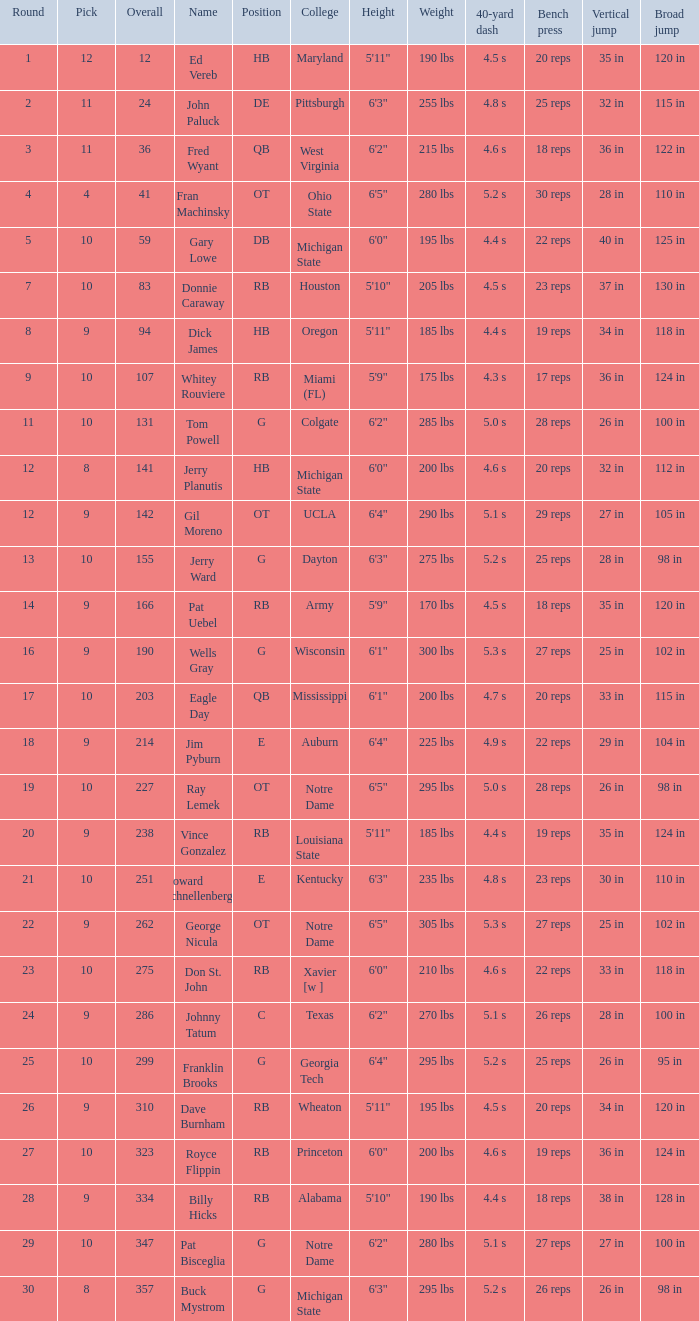What is the highest round number for donnie caraway? 7.0. 